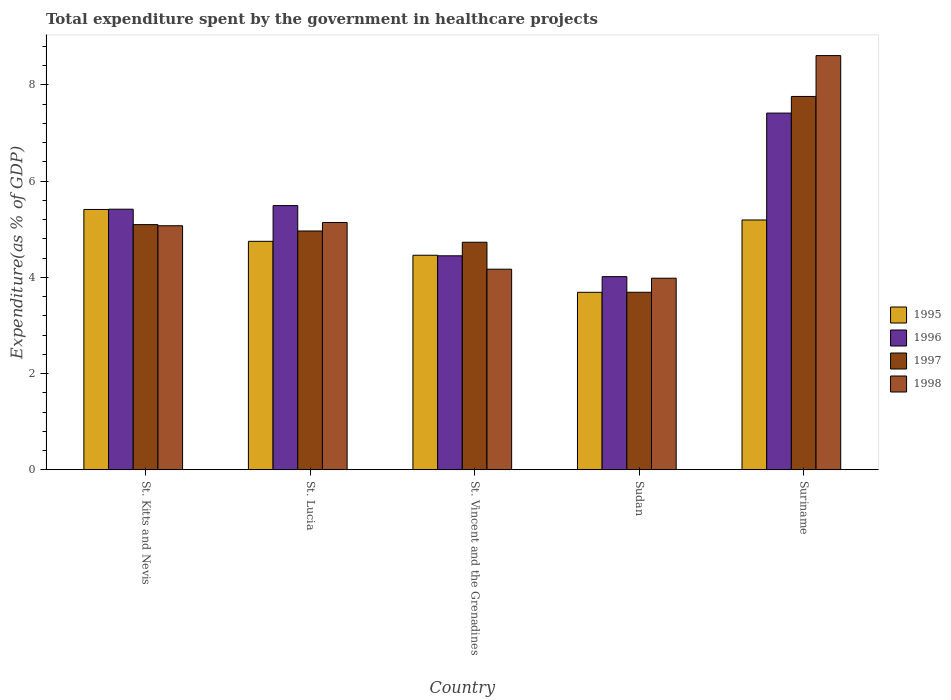Are the number of bars on each tick of the X-axis equal?
Your answer should be compact. Yes. How many bars are there on the 3rd tick from the left?
Your answer should be very brief. 4. What is the label of the 5th group of bars from the left?
Your answer should be very brief. Suriname. In how many cases, is the number of bars for a given country not equal to the number of legend labels?
Offer a terse response. 0. What is the total expenditure spent by the government in healthcare projects in 1995 in Sudan?
Offer a very short reply. 3.69. Across all countries, what is the maximum total expenditure spent by the government in healthcare projects in 1995?
Your answer should be very brief. 5.41. Across all countries, what is the minimum total expenditure spent by the government in healthcare projects in 1996?
Your answer should be compact. 4.01. In which country was the total expenditure spent by the government in healthcare projects in 1995 maximum?
Keep it short and to the point. St. Kitts and Nevis. In which country was the total expenditure spent by the government in healthcare projects in 1996 minimum?
Your answer should be very brief. Sudan. What is the total total expenditure spent by the government in healthcare projects in 1997 in the graph?
Offer a very short reply. 26.23. What is the difference between the total expenditure spent by the government in healthcare projects in 1995 in St. Kitts and Nevis and that in Sudan?
Offer a very short reply. 1.72. What is the difference between the total expenditure spent by the government in healthcare projects in 1998 in Sudan and the total expenditure spent by the government in healthcare projects in 1995 in St. Vincent and the Grenadines?
Provide a succinct answer. -0.48. What is the average total expenditure spent by the government in healthcare projects in 1997 per country?
Offer a very short reply. 5.25. What is the difference between the total expenditure spent by the government in healthcare projects of/in 1996 and total expenditure spent by the government in healthcare projects of/in 1995 in Suriname?
Provide a short and direct response. 2.22. What is the ratio of the total expenditure spent by the government in healthcare projects in 1998 in St. Lucia to that in Suriname?
Give a very brief answer. 0.6. Is the total expenditure spent by the government in healthcare projects in 1997 in St. Kitts and Nevis less than that in Suriname?
Give a very brief answer. Yes. What is the difference between the highest and the second highest total expenditure spent by the government in healthcare projects in 1997?
Make the answer very short. -0.13. What is the difference between the highest and the lowest total expenditure spent by the government in healthcare projects in 1996?
Ensure brevity in your answer.  3.4. Is the sum of the total expenditure spent by the government in healthcare projects in 1998 in St. Lucia and Sudan greater than the maximum total expenditure spent by the government in healthcare projects in 1997 across all countries?
Your answer should be compact. Yes. Is it the case that in every country, the sum of the total expenditure spent by the government in healthcare projects in 1995 and total expenditure spent by the government in healthcare projects in 1996 is greater than the sum of total expenditure spent by the government in healthcare projects in 1997 and total expenditure spent by the government in healthcare projects in 1998?
Keep it short and to the point. No. What does the 2nd bar from the left in St. Vincent and the Grenadines represents?
Offer a terse response. 1996. How many bars are there?
Your answer should be very brief. 20. Are the values on the major ticks of Y-axis written in scientific E-notation?
Give a very brief answer. No. Does the graph contain any zero values?
Ensure brevity in your answer.  No. How are the legend labels stacked?
Your answer should be compact. Vertical. What is the title of the graph?
Ensure brevity in your answer.  Total expenditure spent by the government in healthcare projects. Does "1977" appear as one of the legend labels in the graph?
Keep it short and to the point. No. What is the label or title of the X-axis?
Make the answer very short. Country. What is the label or title of the Y-axis?
Ensure brevity in your answer.  Expenditure(as % of GDP). What is the Expenditure(as % of GDP) in 1995 in St. Kitts and Nevis?
Your answer should be very brief. 5.41. What is the Expenditure(as % of GDP) of 1996 in St. Kitts and Nevis?
Give a very brief answer. 5.41. What is the Expenditure(as % of GDP) of 1997 in St. Kitts and Nevis?
Provide a succinct answer. 5.09. What is the Expenditure(as % of GDP) of 1998 in St. Kitts and Nevis?
Ensure brevity in your answer.  5.07. What is the Expenditure(as % of GDP) of 1995 in St. Lucia?
Offer a terse response. 4.75. What is the Expenditure(as % of GDP) of 1996 in St. Lucia?
Your answer should be compact. 5.49. What is the Expenditure(as % of GDP) in 1997 in St. Lucia?
Offer a very short reply. 4.96. What is the Expenditure(as % of GDP) of 1998 in St. Lucia?
Your response must be concise. 5.14. What is the Expenditure(as % of GDP) of 1995 in St. Vincent and the Grenadines?
Offer a terse response. 4.46. What is the Expenditure(as % of GDP) of 1996 in St. Vincent and the Grenadines?
Provide a short and direct response. 4.45. What is the Expenditure(as % of GDP) of 1997 in St. Vincent and the Grenadines?
Keep it short and to the point. 4.73. What is the Expenditure(as % of GDP) of 1998 in St. Vincent and the Grenadines?
Your response must be concise. 4.17. What is the Expenditure(as % of GDP) of 1995 in Sudan?
Offer a terse response. 3.69. What is the Expenditure(as % of GDP) of 1996 in Sudan?
Your answer should be very brief. 4.01. What is the Expenditure(as % of GDP) in 1997 in Sudan?
Make the answer very short. 3.69. What is the Expenditure(as % of GDP) in 1998 in Sudan?
Ensure brevity in your answer.  3.98. What is the Expenditure(as % of GDP) of 1995 in Suriname?
Your answer should be very brief. 5.19. What is the Expenditure(as % of GDP) in 1996 in Suriname?
Provide a short and direct response. 7.41. What is the Expenditure(as % of GDP) in 1997 in Suriname?
Your answer should be very brief. 7.76. What is the Expenditure(as % of GDP) of 1998 in Suriname?
Offer a very short reply. 8.61. Across all countries, what is the maximum Expenditure(as % of GDP) in 1995?
Offer a terse response. 5.41. Across all countries, what is the maximum Expenditure(as % of GDP) in 1996?
Your answer should be very brief. 7.41. Across all countries, what is the maximum Expenditure(as % of GDP) of 1997?
Ensure brevity in your answer.  7.76. Across all countries, what is the maximum Expenditure(as % of GDP) of 1998?
Offer a terse response. 8.61. Across all countries, what is the minimum Expenditure(as % of GDP) in 1995?
Give a very brief answer. 3.69. Across all countries, what is the minimum Expenditure(as % of GDP) of 1996?
Make the answer very short. 4.01. Across all countries, what is the minimum Expenditure(as % of GDP) in 1997?
Offer a very short reply. 3.69. Across all countries, what is the minimum Expenditure(as % of GDP) in 1998?
Your answer should be compact. 3.98. What is the total Expenditure(as % of GDP) in 1995 in the graph?
Offer a terse response. 23.49. What is the total Expenditure(as % of GDP) in 1996 in the graph?
Offer a terse response. 26.78. What is the total Expenditure(as % of GDP) of 1997 in the graph?
Provide a short and direct response. 26.23. What is the total Expenditure(as % of GDP) of 1998 in the graph?
Keep it short and to the point. 26.97. What is the difference between the Expenditure(as % of GDP) in 1995 in St. Kitts and Nevis and that in St. Lucia?
Offer a very short reply. 0.66. What is the difference between the Expenditure(as % of GDP) in 1996 in St. Kitts and Nevis and that in St. Lucia?
Keep it short and to the point. -0.07. What is the difference between the Expenditure(as % of GDP) in 1997 in St. Kitts and Nevis and that in St. Lucia?
Provide a succinct answer. 0.13. What is the difference between the Expenditure(as % of GDP) in 1998 in St. Kitts and Nevis and that in St. Lucia?
Make the answer very short. -0.07. What is the difference between the Expenditure(as % of GDP) in 1995 in St. Kitts and Nevis and that in St. Vincent and the Grenadines?
Your answer should be very brief. 0.95. What is the difference between the Expenditure(as % of GDP) of 1996 in St. Kitts and Nevis and that in St. Vincent and the Grenadines?
Keep it short and to the point. 0.97. What is the difference between the Expenditure(as % of GDP) of 1997 in St. Kitts and Nevis and that in St. Vincent and the Grenadines?
Offer a terse response. 0.37. What is the difference between the Expenditure(as % of GDP) in 1998 in St. Kitts and Nevis and that in St. Vincent and the Grenadines?
Offer a very short reply. 0.9. What is the difference between the Expenditure(as % of GDP) of 1995 in St. Kitts and Nevis and that in Sudan?
Provide a short and direct response. 1.72. What is the difference between the Expenditure(as % of GDP) of 1996 in St. Kitts and Nevis and that in Sudan?
Your answer should be very brief. 1.4. What is the difference between the Expenditure(as % of GDP) of 1997 in St. Kitts and Nevis and that in Sudan?
Provide a short and direct response. 1.41. What is the difference between the Expenditure(as % of GDP) of 1998 in St. Kitts and Nevis and that in Sudan?
Offer a very short reply. 1.09. What is the difference between the Expenditure(as % of GDP) of 1995 in St. Kitts and Nevis and that in Suriname?
Your answer should be very brief. 0.22. What is the difference between the Expenditure(as % of GDP) in 1996 in St. Kitts and Nevis and that in Suriname?
Your answer should be very brief. -2. What is the difference between the Expenditure(as % of GDP) in 1997 in St. Kitts and Nevis and that in Suriname?
Make the answer very short. -2.66. What is the difference between the Expenditure(as % of GDP) in 1998 in St. Kitts and Nevis and that in Suriname?
Offer a very short reply. -3.54. What is the difference between the Expenditure(as % of GDP) of 1995 in St. Lucia and that in St. Vincent and the Grenadines?
Keep it short and to the point. 0.29. What is the difference between the Expenditure(as % of GDP) of 1996 in St. Lucia and that in St. Vincent and the Grenadines?
Your answer should be very brief. 1.04. What is the difference between the Expenditure(as % of GDP) in 1997 in St. Lucia and that in St. Vincent and the Grenadines?
Give a very brief answer. 0.23. What is the difference between the Expenditure(as % of GDP) in 1998 in St. Lucia and that in St. Vincent and the Grenadines?
Give a very brief answer. 0.97. What is the difference between the Expenditure(as % of GDP) of 1995 in St. Lucia and that in Sudan?
Offer a terse response. 1.06. What is the difference between the Expenditure(as % of GDP) of 1996 in St. Lucia and that in Sudan?
Keep it short and to the point. 1.48. What is the difference between the Expenditure(as % of GDP) in 1997 in St. Lucia and that in Sudan?
Provide a succinct answer. 1.27. What is the difference between the Expenditure(as % of GDP) in 1998 in St. Lucia and that in Sudan?
Give a very brief answer. 1.16. What is the difference between the Expenditure(as % of GDP) in 1995 in St. Lucia and that in Suriname?
Give a very brief answer. -0.44. What is the difference between the Expenditure(as % of GDP) of 1996 in St. Lucia and that in Suriname?
Your answer should be compact. -1.92. What is the difference between the Expenditure(as % of GDP) of 1997 in St. Lucia and that in Suriname?
Make the answer very short. -2.8. What is the difference between the Expenditure(as % of GDP) in 1998 in St. Lucia and that in Suriname?
Offer a very short reply. -3.47. What is the difference between the Expenditure(as % of GDP) of 1995 in St. Vincent and the Grenadines and that in Sudan?
Your response must be concise. 0.77. What is the difference between the Expenditure(as % of GDP) in 1996 in St. Vincent and the Grenadines and that in Sudan?
Your answer should be compact. 0.43. What is the difference between the Expenditure(as % of GDP) in 1997 in St. Vincent and the Grenadines and that in Sudan?
Give a very brief answer. 1.04. What is the difference between the Expenditure(as % of GDP) in 1998 in St. Vincent and the Grenadines and that in Sudan?
Provide a short and direct response. 0.19. What is the difference between the Expenditure(as % of GDP) of 1995 in St. Vincent and the Grenadines and that in Suriname?
Offer a terse response. -0.73. What is the difference between the Expenditure(as % of GDP) in 1996 in St. Vincent and the Grenadines and that in Suriname?
Offer a terse response. -2.97. What is the difference between the Expenditure(as % of GDP) of 1997 in St. Vincent and the Grenadines and that in Suriname?
Your answer should be very brief. -3.03. What is the difference between the Expenditure(as % of GDP) of 1998 in St. Vincent and the Grenadines and that in Suriname?
Offer a terse response. -4.44. What is the difference between the Expenditure(as % of GDP) of 1995 in Sudan and that in Suriname?
Offer a terse response. -1.5. What is the difference between the Expenditure(as % of GDP) in 1996 in Sudan and that in Suriname?
Your answer should be very brief. -3.4. What is the difference between the Expenditure(as % of GDP) of 1997 in Sudan and that in Suriname?
Provide a short and direct response. -4.07. What is the difference between the Expenditure(as % of GDP) in 1998 in Sudan and that in Suriname?
Offer a very short reply. -4.63. What is the difference between the Expenditure(as % of GDP) in 1995 in St. Kitts and Nevis and the Expenditure(as % of GDP) in 1996 in St. Lucia?
Your answer should be very brief. -0.08. What is the difference between the Expenditure(as % of GDP) in 1995 in St. Kitts and Nevis and the Expenditure(as % of GDP) in 1997 in St. Lucia?
Keep it short and to the point. 0.45. What is the difference between the Expenditure(as % of GDP) in 1995 in St. Kitts and Nevis and the Expenditure(as % of GDP) in 1998 in St. Lucia?
Give a very brief answer. 0.27. What is the difference between the Expenditure(as % of GDP) of 1996 in St. Kitts and Nevis and the Expenditure(as % of GDP) of 1997 in St. Lucia?
Ensure brevity in your answer.  0.45. What is the difference between the Expenditure(as % of GDP) in 1996 in St. Kitts and Nevis and the Expenditure(as % of GDP) in 1998 in St. Lucia?
Your answer should be very brief. 0.28. What is the difference between the Expenditure(as % of GDP) of 1997 in St. Kitts and Nevis and the Expenditure(as % of GDP) of 1998 in St. Lucia?
Provide a short and direct response. -0.04. What is the difference between the Expenditure(as % of GDP) of 1995 in St. Kitts and Nevis and the Expenditure(as % of GDP) of 1997 in St. Vincent and the Grenadines?
Offer a very short reply. 0.68. What is the difference between the Expenditure(as % of GDP) in 1995 in St. Kitts and Nevis and the Expenditure(as % of GDP) in 1998 in St. Vincent and the Grenadines?
Your answer should be compact. 1.24. What is the difference between the Expenditure(as % of GDP) in 1996 in St. Kitts and Nevis and the Expenditure(as % of GDP) in 1997 in St. Vincent and the Grenadines?
Your answer should be compact. 0.69. What is the difference between the Expenditure(as % of GDP) in 1996 in St. Kitts and Nevis and the Expenditure(as % of GDP) in 1998 in St. Vincent and the Grenadines?
Give a very brief answer. 1.25. What is the difference between the Expenditure(as % of GDP) in 1997 in St. Kitts and Nevis and the Expenditure(as % of GDP) in 1998 in St. Vincent and the Grenadines?
Offer a very short reply. 0.93. What is the difference between the Expenditure(as % of GDP) in 1995 in St. Kitts and Nevis and the Expenditure(as % of GDP) in 1996 in Sudan?
Your response must be concise. 1.4. What is the difference between the Expenditure(as % of GDP) in 1995 in St. Kitts and Nevis and the Expenditure(as % of GDP) in 1997 in Sudan?
Make the answer very short. 1.72. What is the difference between the Expenditure(as % of GDP) of 1995 in St. Kitts and Nevis and the Expenditure(as % of GDP) of 1998 in Sudan?
Make the answer very short. 1.43. What is the difference between the Expenditure(as % of GDP) of 1996 in St. Kitts and Nevis and the Expenditure(as % of GDP) of 1997 in Sudan?
Ensure brevity in your answer.  1.73. What is the difference between the Expenditure(as % of GDP) of 1996 in St. Kitts and Nevis and the Expenditure(as % of GDP) of 1998 in Sudan?
Your answer should be compact. 1.43. What is the difference between the Expenditure(as % of GDP) in 1997 in St. Kitts and Nevis and the Expenditure(as % of GDP) in 1998 in Sudan?
Ensure brevity in your answer.  1.11. What is the difference between the Expenditure(as % of GDP) in 1995 in St. Kitts and Nevis and the Expenditure(as % of GDP) in 1996 in Suriname?
Give a very brief answer. -2. What is the difference between the Expenditure(as % of GDP) in 1995 in St. Kitts and Nevis and the Expenditure(as % of GDP) in 1997 in Suriname?
Ensure brevity in your answer.  -2.35. What is the difference between the Expenditure(as % of GDP) in 1995 in St. Kitts and Nevis and the Expenditure(as % of GDP) in 1998 in Suriname?
Your response must be concise. -3.2. What is the difference between the Expenditure(as % of GDP) of 1996 in St. Kitts and Nevis and the Expenditure(as % of GDP) of 1997 in Suriname?
Make the answer very short. -2.34. What is the difference between the Expenditure(as % of GDP) in 1996 in St. Kitts and Nevis and the Expenditure(as % of GDP) in 1998 in Suriname?
Offer a terse response. -3.19. What is the difference between the Expenditure(as % of GDP) of 1997 in St. Kitts and Nevis and the Expenditure(as % of GDP) of 1998 in Suriname?
Make the answer very short. -3.51. What is the difference between the Expenditure(as % of GDP) in 1995 in St. Lucia and the Expenditure(as % of GDP) in 1996 in St. Vincent and the Grenadines?
Provide a succinct answer. 0.3. What is the difference between the Expenditure(as % of GDP) in 1995 in St. Lucia and the Expenditure(as % of GDP) in 1997 in St. Vincent and the Grenadines?
Provide a short and direct response. 0.02. What is the difference between the Expenditure(as % of GDP) of 1995 in St. Lucia and the Expenditure(as % of GDP) of 1998 in St. Vincent and the Grenadines?
Provide a short and direct response. 0.58. What is the difference between the Expenditure(as % of GDP) of 1996 in St. Lucia and the Expenditure(as % of GDP) of 1997 in St. Vincent and the Grenadines?
Make the answer very short. 0.76. What is the difference between the Expenditure(as % of GDP) of 1996 in St. Lucia and the Expenditure(as % of GDP) of 1998 in St. Vincent and the Grenadines?
Provide a short and direct response. 1.32. What is the difference between the Expenditure(as % of GDP) of 1997 in St. Lucia and the Expenditure(as % of GDP) of 1998 in St. Vincent and the Grenadines?
Offer a very short reply. 0.79. What is the difference between the Expenditure(as % of GDP) in 1995 in St. Lucia and the Expenditure(as % of GDP) in 1996 in Sudan?
Your answer should be very brief. 0.73. What is the difference between the Expenditure(as % of GDP) in 1995 in St. Lucia and the Expenditure(as % of GDP) in 1997 in Sudan?
Keep it short and to the point. 1.06. What is the difference between the Expenditure(as % of GDP) of 1995 in St. Lucia and the Expenditure(as % of GDP) of 1998 in Sudan?
Keep it short and to the point. 0.77. What is the difference between the Expenditure(as % of GDP) of 1996 in St. Lucia and the Expenditure(as % of GDP) of 1997 in Sudan?
Your answer should be very brief. 1.8. What is the difference between the Expenditure(as % of GDP) in 1996 in St. Lucia and the Expenditure(as % of GDP) in 1998 in Sudan?
Ensure brevity in your answer.  1.51. What is the difference between the Expenditure(as % of GDP) of 1995 in St. Lucia and the Expenditure(as % of GDP) of 1996 in Suriname?
Keep it short and to the point. -2.66. What is the difference between the Expenditure(as % of GDP) in 1995 in St. Lucia and the Expenditure(as % of GDP) in 1997 in Suriname?
Your response must be concise. -3.01. What is the difference between the Expenditure(as % of GDP) in 1995 in St. Lucia and the Expenditure(as % of GDP) in 1998 in Suriname?
Provide a short and direct response. -3.86. What is the difference between the Expenditure(as % of GDP) in 1996 in St. Lucia and the Expenditure(as % of GDP) in 1997 in Suriname?
Offer a very short reply. -2.27. What is the difference between the Expenditure(as % of GDP) of 1996 in St. Lucia and the Expenditure(as % of GDP) of 1998 in Suriname?
Ensure brevity in your answer.  -3.12. What is the difference between the Expenditure(as % of GDP) of 1997 in St. Lucia and the Expenditure(as % of GDP) of 1998 in Suriname?
Make the answer very short. -3.64. What is the difference between the Expenditure(as % of GDP) of 1995 in St. Vincent and the Grenadines and the Expenditure(as % of GDP) of 1996 in Sudan?
Provide a short and direct response. 0.44. What is the difference between the Expenditure(as % of GDP) of 1995 in St. Vincent and the Grenadines and the Expenditure(as % of GDP) of 1997 in Sudan?
Ensure brevity in your answer.  0.77. What is the difference between the Expenditure(as % of GDP) in 1995 in St. Vincent and the Grenadines and the Expenditure(as % of GDP) in 1998 in Sudan?
Your answer should be very brief. 0.48. What is the difference between the Expenditure(as % of GDP) in 1996 in St. Vincent and the Grenadines and the Expenditure(as % of GDP) in 1997 in Sudan?
Offer a very short reply. 0.76. What is the difference between the Expenditure(as % of GDP) of 1996 in St. Vincent and the Grenadines and the Expenditure(as % of GDP) of 1998 in Sudan?
Offer a terse response. 0.47. What is the difference between the Expenditure(as % of GDP) of 1997 in St. Vincent and the Grenadines and the Expenditure(as % of GDP) of 1998 in Sudan?
Your answer should be very brief. 0.75. What is the difference between the Expenditure(as % of GDP) of 1995 in St. Vincent and the Grenadines and the Expenditure(as % of GDP) of 1996 in Suriname?
Your response must be concise. -2.95. What is the difference between the Expenditure(as % of GDP) in 1995 in St. Vincent and the Grenadines and the Expenditure(as % of GDP) in 1997 in Suriname?
Provide a short and direct response. -3.3. What is the difference between the Expenditure(as % of GDP) of 1995 in St. Vincent and the Grenadines and the Expenditure(as % of GDP) of 1998 in Suriname?
Your answer should be compact. -4.15. What is the difference between the Expenditure(as % of GDP) of 1996 in St. Vincent and the Grenadines and the Expenditure(as % of GDP) of 1997 in Suriname?
Keep it short and to the point. -3.31. What is the difference between the Expenditure(as % of GDP) in 1996 in St. Vincent and the Grenadines and the Expenditure(as % of GDP) in 1998 in Suriname?
Make the answer very short. -4.16. What is the difference between the Expenditure(as % of GDP) in 1997 in St. Vincent and the Grenadines and the Expenditure(as % of GDP) in 1998 in Suriname?
Your response must be concise. -3.88. What is the difference between the Expenditure(as % of GDP) of 1995 in Sudan and the Expenditure(as % of GDP) of 1996 in Suriname?
Make the answer very short. -3.72. What is the difference between the Expenditure(as % of GDP) of 1995 in Sudan and the Expenditure(as % of GDP) of 1997 in Suriname?
Provide a short and direct response. -4.07. What is the difference between the Expenditure(as % of GDP) of 1995 in Sudan and the Expenditure(as % of GDP) of 1998 in Suriname?
Provide a short and direct response. -4.92. What is the difference between the Expenditure(as % of GDP) of 1996 in Sudan and the Expenditure(as % of GDP) of 1997 in Suriname?
Provide a succinct answer. -3.74. What is the difference between the Expenditure(as % of GDP) in 1996 in Sudan and the Expenditure(as % of GDP) in 1998 in Suriname?
Offer a very short reply. -4.59. What is the difference between the Expenditure(as % of GDP) in 1997 in Sudan and the Expenditure(as % of GDP) in 1998 in Suriname?
Keep it short and to the point. -4.92. What is the average Expenditure(as % of GDP) in 1995 per country?
Give a very brief answer. 4.7. What is the average Expenditure(as % of GDP) in 1996 per country?
Your answer should be compact. 5.36. What is the average Expenditure(as % of GDP) of 1997 per country?
Your answer should be compact. 5.25. What is the average Expenditure(as % of GDP) of 1998 per country?
Offer a very short reply. 5.39. What is the difference between the Expenditure(as % of GDP) in 1995 and Expenditure(as % of GDP) in 1996 in St. Kitts and Nevis?
Your answer should be very brief. -0.01. What is the difference between the Expenditure(as % of GDP) in 1995 and Expenditure(as % of GDP) in 1997 in St. Kitts and Nevis?
Provide a short and direct response. 0.32. What is the difference between the Expenditure(as % of GDP) in 1995 and Expenditure(as % of GDP) in 1998 in St. Kitts and Nevis?
Your answer should be very brief. 0.34. What is the difference between the Expenditure(as % of GDP) of 1996 and Expenditure(as % of GDP) of 1997 in St. Kitts and Nevis?
Ensure brevity in your answer.  0.32. What is the difference between the Expenditure(as % of GDP) of 1996 and Expenditure(as % of GDP) of 1998 in St. Kitts and Nevis?
Give a very brief answer. 0.34. What is the difference between the Expenditure(as % of GDP) of 1997 and Expenditure(as % of GDP) of 1998 in St. Kitts and Nevis?
Ensure brevity in your answer.  0.02. What is the difference between the Expenditure(as % of GDP) in 1995 and Expenditure(as % of GDP) in 1996 in St. Lucia?
Provide a short and direct response. -0.74. What is the difference between the Expenditure(as % of GDP) in 1995 and Expenditure(as % of GDP) in 1997 in St. Lucia?
Ensure brevity in your answer.  -0.21. What is the difference between the Expenditure(as % of GDP) of 1995 and Expenditure(as % of GDP) of 1998 in St. Lucia?
Ensure brevity in your answer.  -0.39. What is the difference between the Expenditure(as % of GDP) of 1996 and Expenditure(as % of GDP) of 1997 in St. Lucia?
Offer a very short reply. 0.53. What is the difference between the Expenditure(as % of GDP) of 1996 and Expenditure(as % of GDP) of 1998 in St. Lucia?
Give a very brief answer. 0.35. What is the difference between the Expenditure(as % of GDP) of 1997 and Expenditure(as % of GDP) of 1998 in St. Lucia?
Offer a very short reply. -0.18. What is the difference between the Expenditure(as % of GDP) of 1995 and Expenditure(as % of GDP) of 1996 in St. Vincent and the Grenadines?
Provide a short and direct response. 0.01. What is the difference between the Expenditure(as % of GDP) in 1995 and Expenditure(as % of GDP) in 1997 in St. Vincent and the Grenadines?
Give a very brief answer. -0.27. What is the difference between the Expenditure(as % of GDP) of 1995 and Expenditure(as % of GDP) of 1998 in St. Vincent and the Grenadines?
Give a very brief answer. 0.29. What is the difference between the Expenditure(as % of GDP) of 1996 and Expenditure(as % of GDP) of 1997 in St. Vincent and the Grenadines?
Provide a succinct answer. -0.28. What is the difference between the Expenditure(as % of GDP) of 1996 and Expenditure(as % of GDP) of 1998 in St. Vincent and the Grenadines?
Ensure brevity in your answer.  0.28. What is the difference between the Expenditure(as % of GDP) of 1997 and Expenditure(as % of GDP) of 1998 in St. Vincent and the Grenadines?
Keep it short and to the point. 0.56. What is the difference between the Expenditure(as % of GDP) in 1995 and Expenditure(as % of GDP) in 1996 in Sudan?
Make the answer very short. -0.33. What is the difference between the Expenditure(as % of GDP) in 1995 and Expenditure(as % of GDP) in 1997 in Sudan?
Ensure brevity in your answer.  -0. What is the difference between the Expenditure(as % of GDP) of 1995 and Expenditure(as % of GDP) of 1998 in Sudan?
Provide a short and direct response. -0.29. What is the difference between the Expenditure(as % of GDP) in 1996 and Expenditure(as % of GDP) in 1997 in Sudan?
Provide a short and direct response. 0.32. What is the difference between the Expenditure(as % of GDP) in 1996 and Expenditure(as % of GDP) in 1998 in Sudan?
Provide a short and direct response. 0.03. What is the difference between the Expenditure(as % of GDP) of 1997 and Expenditure(as % of GDP) of 1998 in Sudan?
Ensure brevity in your answer.  -0.29. What is the difference between the Expenditure(as % of GDP) in 1995 and Expenditure(as % of GDP) in 1996 in Suriname?
Provide a succinct answer. -2.22. What is the difference between the Expenditure(as % of GDP) of 1995 and Expenditure(as % of GDP) of 1997 in Suriname?
Provide a succinct answer. -2.57. What is the difference between the Expenditure(as % of GDP) in 1995 and Expenditure(as % of GDP) in 1998 in Suriname?
Your answer should be very brief. -3.42. What is the difference between the Expenditure(as % of GDP) of 1996 and Expenditure(as % of GDP) of 1997 in Suriname?
Offer a very short reply. -0.35. What is the difference between the Expenditure(as % of GDP) in 1996 and Expenditure(as % of GDP) in 1998 in Suriname?
Offer a very short reply. -1.19. What is the difference between the Expenditure(as % of GDP) of 1997 and Expenditure(as % of GDP) of 1998 in Suriname?
Provide a short and direct response. -0.85. What is the ratio of the Expenditure(as % of GDP) in 1995 in St. Kitts and Nevis to that in St. Lucia?
Make the answer very short. 1.14. What is the ratio of the Expenditure(as % of GDP) of 1996 in St. Kitts and Nevis to that in St. Lucia?
Your answer should be very brief. 0.99. What is the ratio of the Expenditure(as % of GDP) of 1997 in St. Kitts and Nevis to that in St. Lucia?
Ensure brevity in your answer.  1.03. What is the ratio of the Expenditure(as % of GDP) in 1995 in St. Kitts and Nevis to that in St. Vincent and the Grenadines?
Provide a short and direct response. 1.21. What is the ratio of the Expenditure(as % of GDP) in 1996 in St. Kitts and Nevis to that in St. Vincent and the Grenadines?
Your response must be concise. 1.22. What is the ratio of the Expenditure(as % of GDP) of 1997 in St. Kitts and Nevis to that in St. Vincent and the Grenadines?
Your answer should be compact. 1.08. What is the ratio of the Expenditure(as % of GDP) of 1998 in St. Kitts and Nevis to that in St. Vincent and the Grenadines?
Provide a short and direct response. 1.22. What is the ratio of the Expenditure(as % of GDP) in 1995 in St. Kitts and Nevis to that in Sudan?
Offer a very short reply. 1.47. What is the ratio of the Expenditure(as % of GDP) in 1996 in St. Kitts and Nevis to that in Sudan?
Provide a succinct answer. 1.35. What is the ratio of the Expenditure(as % of GDP) of 1997 in St. Kitts and Nevis to that in Sudan?
Make the answer very short. 1.38. What is the ratio of the Expenditure(as % of GDP) in 1998 in St. Kitts and Nevis to that in Sudan?
Keep it short and to the point. 1.27. What is the ratio of the Expenditure(as % of GDP) in 1995 in St. Kitts and Nevis to that in Suriname?
Offer a very short reply. 1.04. What is the ratio of the Expenditure(as % of GDP) of 1996 in St. Kitts and Nevis to that in Suriname?
Provide a succinct answer. 0.73. What is the ratio of the Expenditure(as % of GDP) of 1997 in St. Kitts and Nevis to that in Suriname?
Keep it short and to the point. 0.66. What is the ratio of the Expenditure(as % of GDP) in 1998 in St. Kitts and Nevis to that in Suriname?
Provide a succinct answer. 0.59. What is the ratio of the Expenditure(as % of GDP) in 1995 in St. Lucia to that in St. Vincent and the Grenadines?
Offer a terse response. 1.06. What is the ratio of the Expenditure(as % of GDP) in 1996 in St. Lucia to that in St. Vincent and the Grenadines?
Provide a succinct answer. 1.23. What is the ratio of the Expenditure(as % of GDP) of 1997 in St. Lucia to that in St. Vincent and the Grenadines?
Give a very brief answer. 1.05. What is the ratio of the Expenditure(as % of GDP) of 1998 in St. Lucia to that in St. Vincent and the Grenadines?
Provide a short and direct response. 1.23. What is the ratio of the Expenditure(as % of GDP) in 1995 in St. Lucia to that in Sudan?
Offer a terse response. 1.29. What is the ratio of the Expenditure(as % of GDP) in 1996 in St. Lucia to that in Sudan?
Keep it short and to the point. 1.37. What is the ratio of the Expenditure(as % of GDP) in 1997 in St. Lucia to that in Sudan?
Your response must be concise. 1.35. What is the ratio of the Expenditure(as % of GDP) of 1998 in St. Lucia to that in Sudan?
Ensure brevity in your answer.  1.29. What is the ratio of the Expenditure(as % of GDP) of 1995 in St. Lucia to that in Suriname?
Offer a very short reply. 0.91. What is the ratio of the Expenditure(as % of GDP) of 1996 in St. Lucia to that in Suriname?
Your answer should be very brief. 0.74. What is the ratio of the Expenditure(as % of GDP) in 1997 in St. Lucia to that in Suriname?
Offer a terse response. 0.64. What is the ratio of the Expenditure(as % of GDP) in 1998 in St. Lucia to that in Suriname?
Your answer should be very brief. 0.6. What is the ratio of the Expenditure(as % of GDP) in 1995 in St. Vincent and the Grenadines to that in Sudan?
Offer a terse response. 1.21. What is the ratio of the Expenditure(as % of GDP) in 1996 in St. Vincent and the Grenadines to that in Sudan?
Your response must be concise. 1.11. What is the ratio of the Expenditure(as % of GDP) of 1997 in St. Vincent and the Grenadines to that in Sudan?
Make the answer very short. 1.28. What is the ratio of the Expenditure(as % of GDP) in 1998 in St. Vincent and the Grenadines to that in Sudan?
Provide a succinct answer. 1.05. What is the ratio of the Expenditure(as % of GDP) of 1995 in St. Vincent and the Grenadines to that in Suriname?
Ensure brevity in your answer.  0.86. What is the ratio of the Expenditure(as % of GDP) in 1996 in St. Vincent and the Grenadines to that in Suriname?
Offer a terse response. 0.6. What is the ratio of the Expenditure(as % of GDP) in 1997 in St. Vincent and the Grenadines to that in Suriname?
Make the answer very short. 0.61. What is the ratio of the Expenditure(as % of GDP) of 1998 in St. Vincent and the Grenadines to that in Suriname?
Keep it short and to the point. 0.48. What is the ratio of the Expenditure(as % of GDP) in 1995 in Sudan to that in Suriname?
Provide a succinct answer. 0.71. What is the ratio of the Expenditure(as % of GDP) of 1996 in Sudan to that in Suriname?
Give a very brief answer. 0.54. What is the ratio of the Expenditure(as % of GDP) in 1997 in Sudan to that in Suriname?
Offer a very short reply. 0.48. What is the ratio of the Expenditure(as % of GDP) in 1998 in Sudan to that in Suriname?
Ensure brevity in your answer.  0.46. What is the difference between the highest and the second highest Expenditure(as % of GDP) of 1995?
Keep it short and to the point. 0.22. What is the difference between the highest and the second highest Expenditure(as % of GDP) in 1996?
Your response must be concise. 1.92. What is the difference between the highest and the second highest Expenditure(as % of GDP) in 1997?
Provide a short and direct response. 2.66. What is the difference between the highest and the second highest Expenditure(as % of GDP) in 1998?
Offer a terse response. 3.47. What is the difference between the highest and the lowest Expenditure(as % of GDP) in 1995?
Provide a short and direct response. 1.72. What is the difference between the highest and the lowest Expenditure(as % of GDP) of 1996?
Give a very brief answer. 3.4. What is the difference between the highest and the lowest Expenditure(as % of GDP) in 1997?
Keep it short and to the point. 4.07. What is the difference between the highest and the lowest Expenditure(as % of GDP) in 1998?
Your response must be concise. 4.63. 